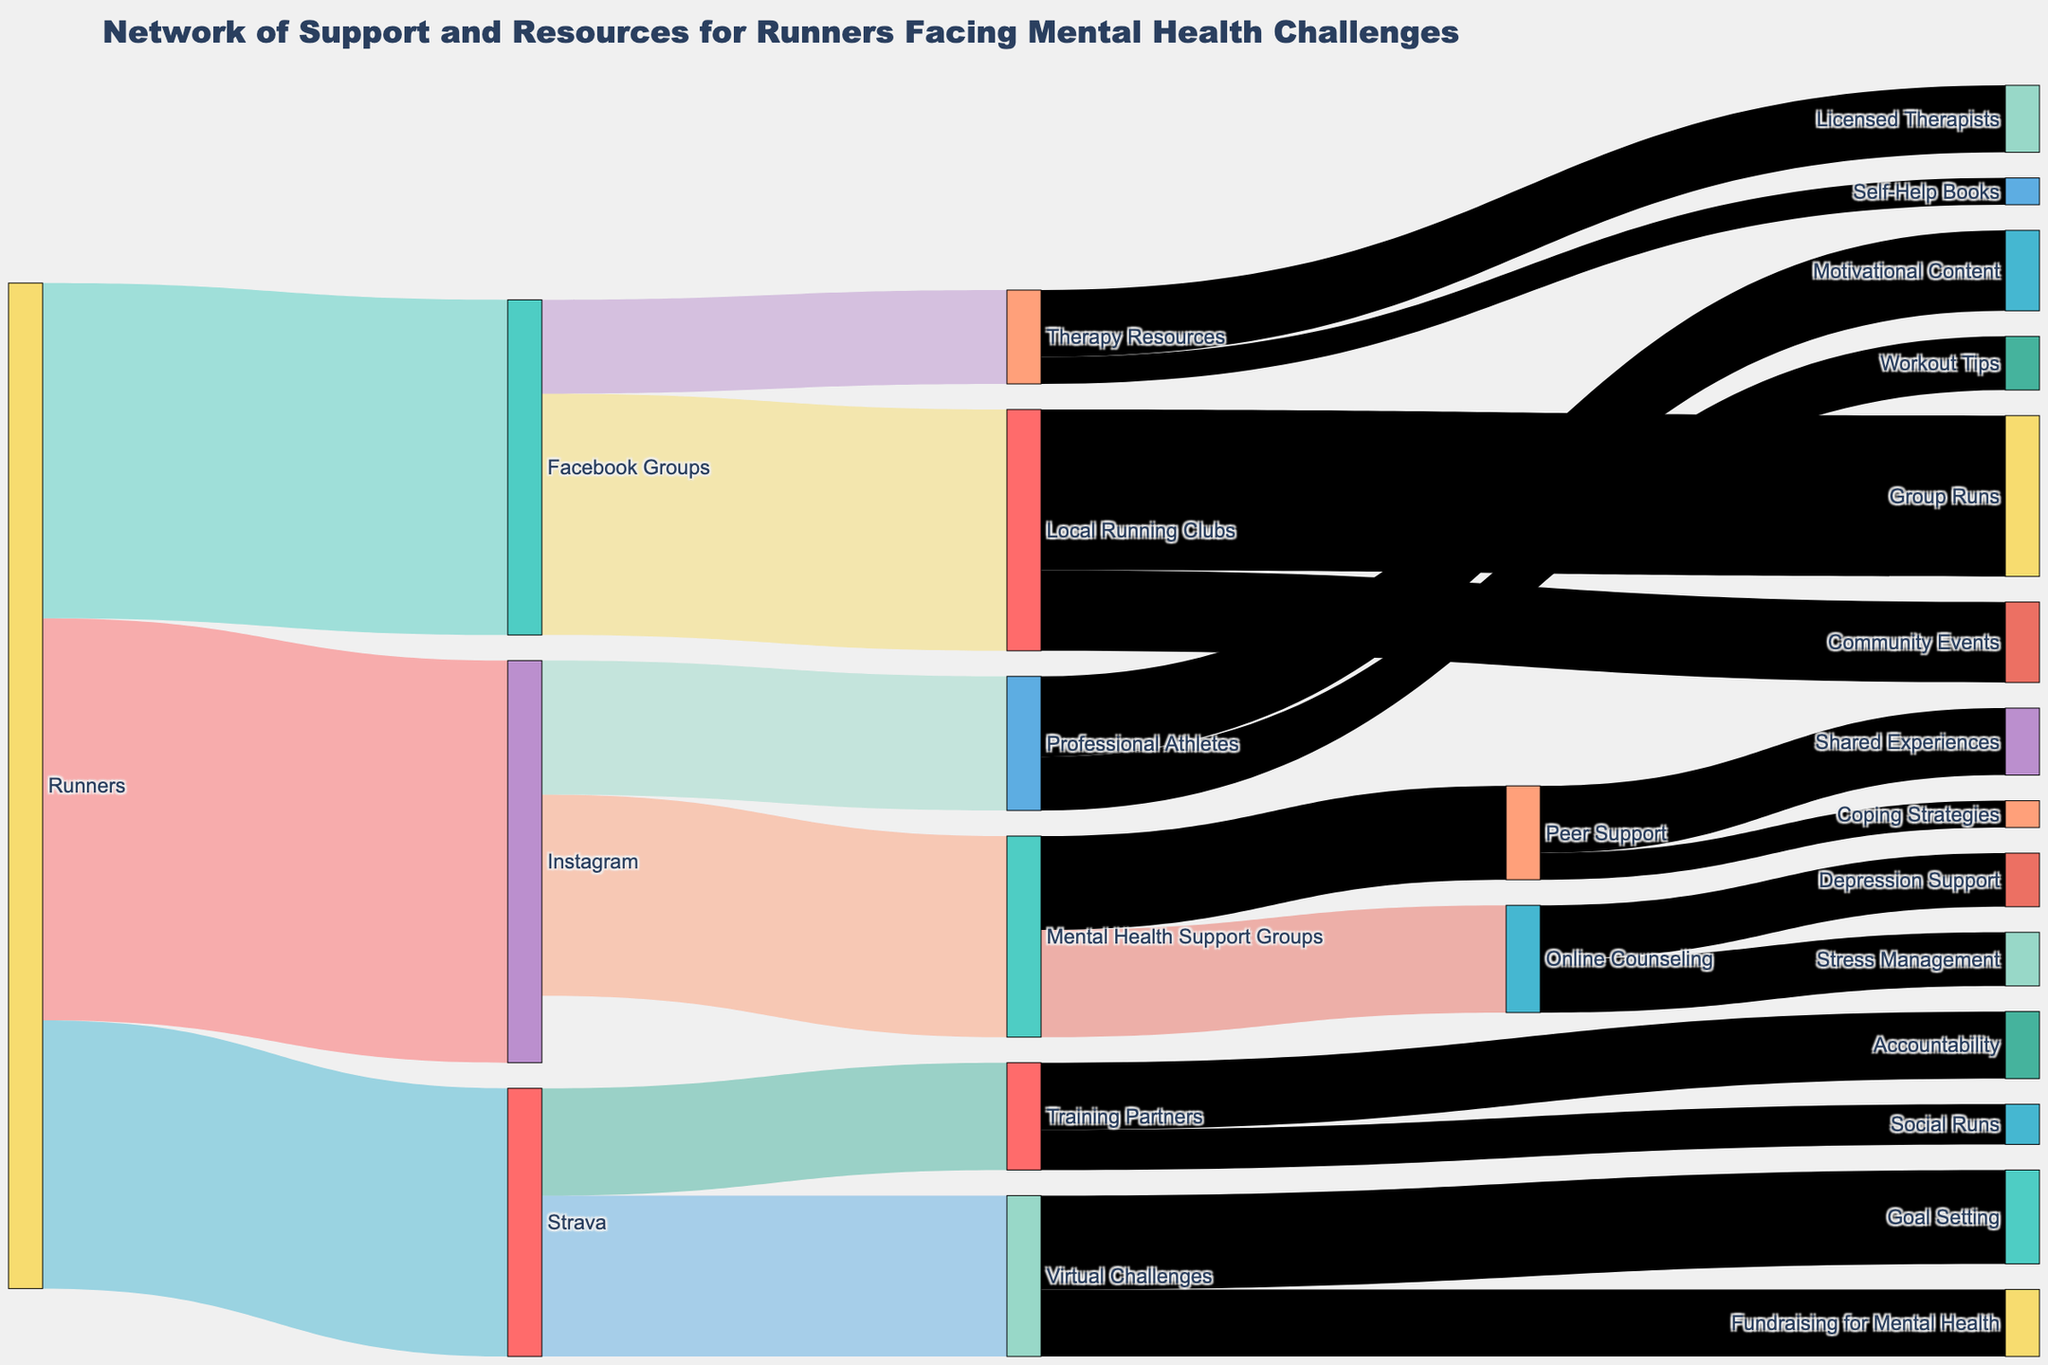What's the most common social media platform used by runners for mental health support? The Sankey diagram shows initial connections from "Runners" to various social media platforms. To find the most common one, compare the values of the connections from "Runners" to "Instagram," "Facebook Groups," and "Strava." The highest value among these is 300 for "Instagram."
Answer: Instagram What type of resource has the highest number of connections stemming from Facebook Groups? Check the connections starting from "Facebook Groups" and compare the values going to "Local Running Clubs" and "Therapy Resources." The connection with the highest value is 180, which goes to "Local Running Clubs."
Answer: Local Running Clubs How many total resources and support channels are accessed through Instagram? Look at the connections going out from "Instagram" and sum their values. The values are 150 for "Mental Health Support Groups" and 100 for "Professional Athletes." Adding these gives 150 + 100 = 250.
Answer: 250 Which resource linked to "Strava" has a greater value, Virtual Challenges or Training Partners? Compare the values of connections from "Strava" to "Virtual Challenges" and "Training Partners." The value for "Virtual Challenges" is 120, while for "Training Partners" it is 80.
Answer: Virtual Challenges Which resource stemming from "Therapy Resources" has the smaller value? Look at the connections starting from "Therapy Resources." Compare the values for "Licensed Therapists" and "Self-Help Books." The values are 50 and 20, respectively. The smaller value is 20 for "Self-Help Books."
Answer: Self-Help Books What is the total value of runners accessing resources through Facebook Groups and Strava combined? Add the values from "Runners" to "Facebook Groups" and "Strava." The values are 250 and 200, respectively. So, 250 + 200 = 450.
Answer: 450 If you combine the connections leading from "Local Running Clubs," what is the total value? Sum the values of the connections from "Local Running Clubs" to "Group Runs" and "Community Events." The values are 120 and 60, respectively. So, 120 + 60 = 180.
Answer: 180 What is the difference in value between connections from "Mental Health Support Groups" to "Online Counseling" and "Peer Support"? Subtract the value of the connection to "Peer Support" from the value of the connection to "Online Counseling." The values are 80 and 70, respectively, so 80 - 70 = 10.
Answer: 10 Which resource linked through "Training Partners" does not primarily involve running? Look at the connections from "Training Partners" to identify what types of support they represent. The connections are to "Accountability" and "Social Runs." "Accountability" does not necessarily involve running.
Answer: Accountability 